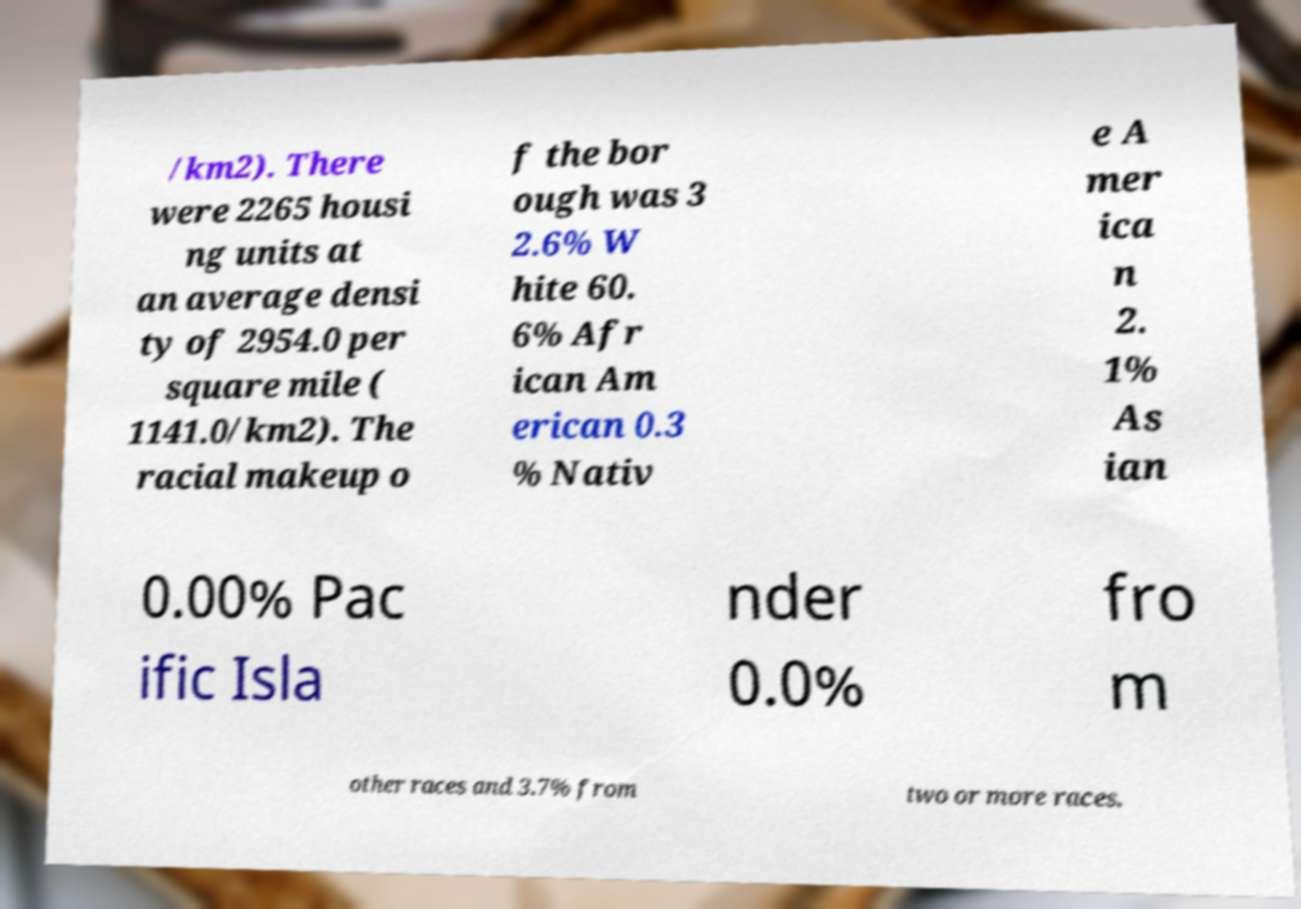Could you extract and type out the text from this image? /km2). There were 2265 housi ng units at an average densi ty of 2954.0 per square mile ( 1141.0/km2). The racial makeup o f the bor ough was 3 2.6% W hite 60. 6% Afr ican Am erican 0.3 % Nativ e A mer ica n 2. 1% As ian 0.00% Pac ific Isla nder 0.0% fro m other races and 3.7% from two or more races. 